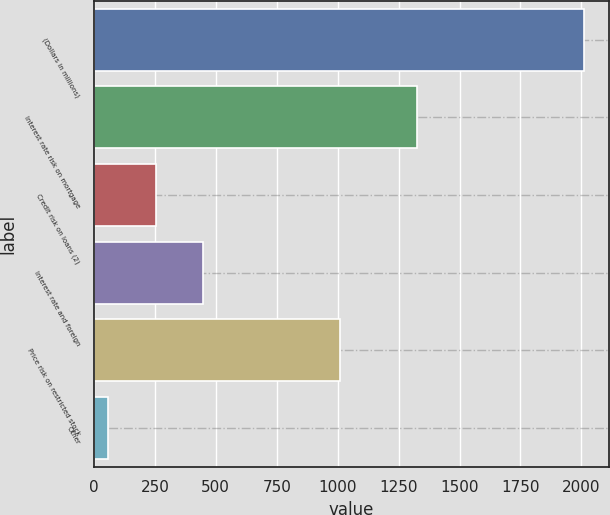<chart> <loc_0><loc_0><loc_500><loc_500><bar_chart><fcel>(Dollars in millions)<fcel>Interest rate risk on mortgage<fcel>Credit risk on loans (2)<fcel>Interest rate and foreign<fcel>Price risk on restricted stock<fcel>Other<nl><fcel>2012<fcel>1324<fcel>253.4<fcel>448.8<fcel>1008<fcel>58<nl></chart> 